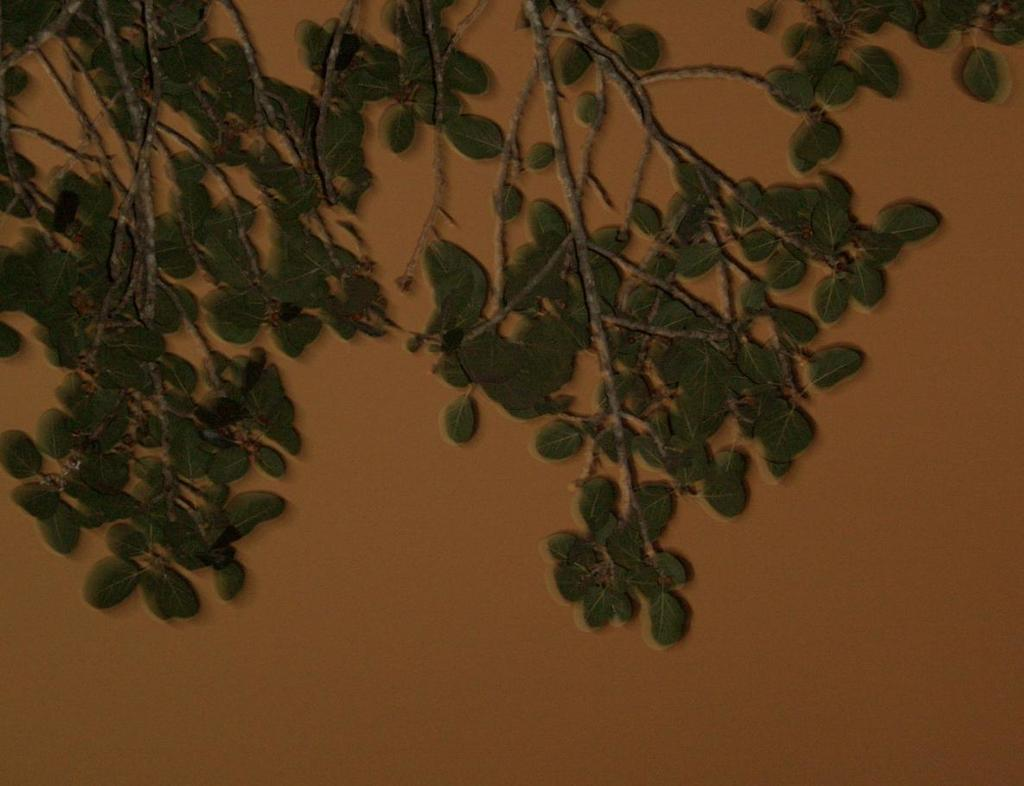What type of vegetation can be seen in the image? There are branches with leaves in the image. What can be seen in the background of the image? There is a wall visible in the background of the image. What color is the copper wire wrapped around the branches in the image? There is no copper wire present in the image; it only features branches with leaves and a wall in the background. 